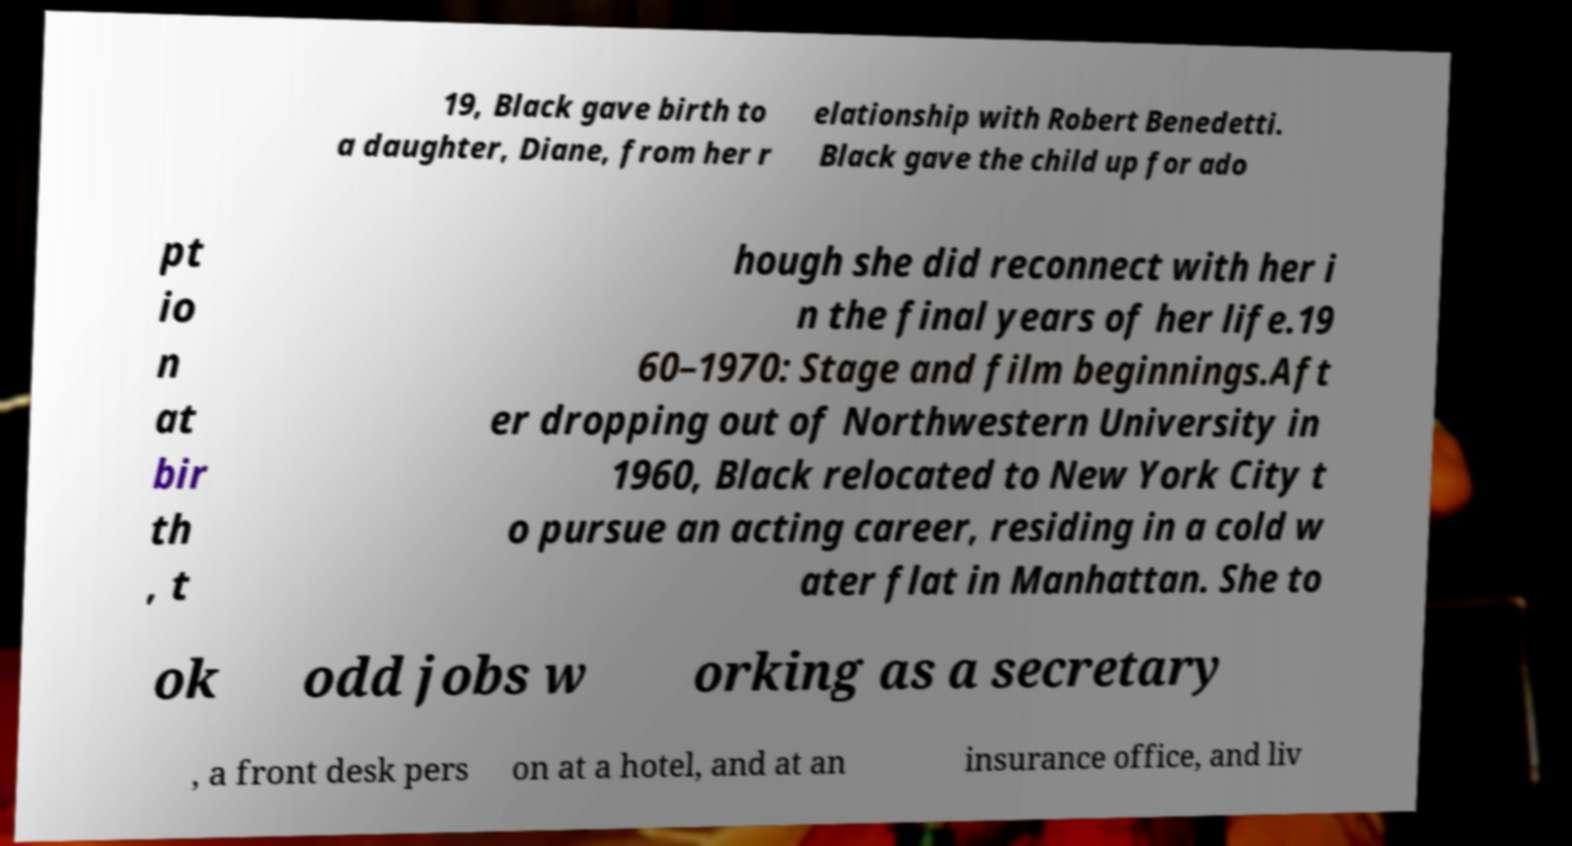I need the written content from this picture converted into text. Can you do that? 19, Black gave birth to a daughter, Diane, from her r elationship with Robert Benedetti. Black gave the child up for ado pt io n at bir th , t hough she did reconnect with her i n the final years of her life.19 60–1970: Stage and film beginnings.Aft er dropping out of Northwestern University in 1960, Black relocated to New York City t o pursue an acting career, residing in a cold w ater flat in Manhattan. She to ok odd jobs w orking as a secretary , a front desk pers on at a hotel, and at an insurance office, and liv 